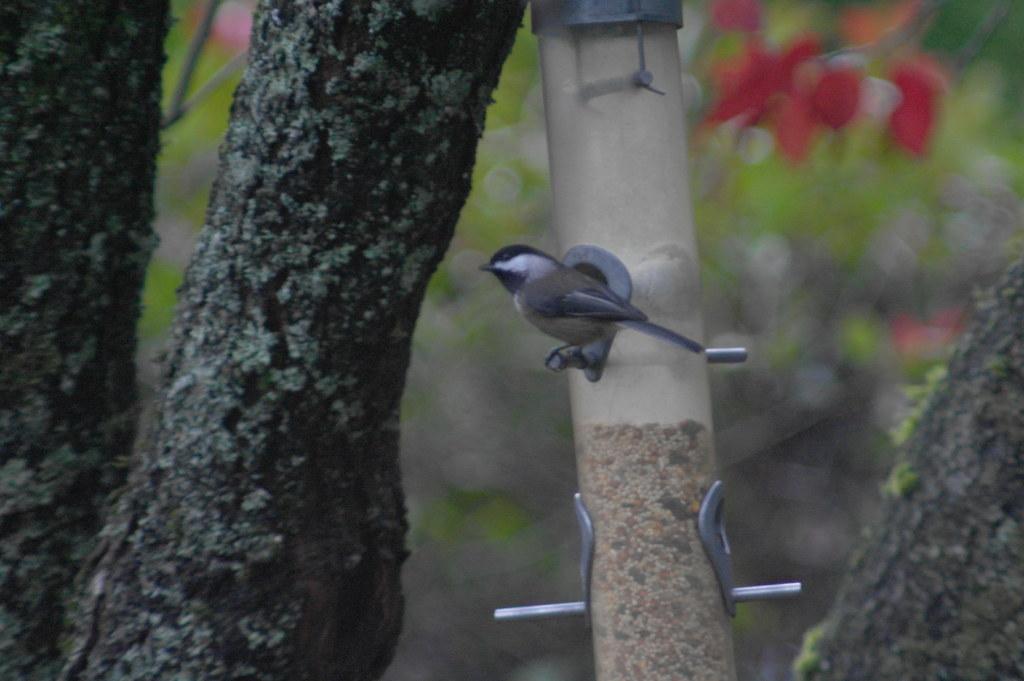How would you summarize this image in a sentence or two? In this picture I can observe a bird on the pole. On the left side I can observe tree. The background is blurred. 